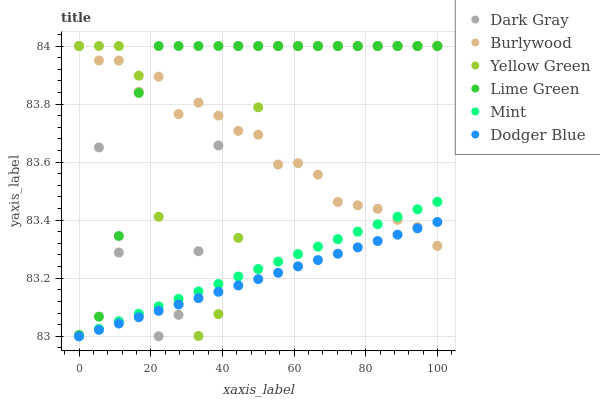Does Dodger Blue have the minimum area under the curve?
Answer yes or no. Yes. Does Lime Green have the maximum area under the curve?
Answer yes or no. Yes. Does Burlywood have the minimum area under the curve?
Answer yes or no. No. Does Burlywood have the maximum area under the curve?
Answer yes or no. No. Is Mint the smoothest?
Answer yes or no. Yes. Is Yellow Green the roughest?
Answer yes or no. Yes. Is Burlywood the smoothest?
Answer yes or no. No. Is Burlywood the roughest?
Answer yes or no. No. Does Dodger Blue have the lowest value?
Answer yes or no. Yes. Does Lime Green have the lowest value?
Answer yes or no. No. Does Dark Gray have the highest value?
Answer yes or no. Yes. Does Dodger Blue have the highest value?
Answer yes or no. No. Is Dodger Blue less than Lime Green?
Answer yes or no. Yes. Is Lime Green greater than Mint?
Answer yes or no. Yes. Does Yellow Green intersect Dodger Blue?
Answer yes or no. Yes. Is Yellow Green less than Dodger Blue?
Answer yes or no. No. Is Yellow Green greater than Dodger Blue?
Answer yes or no. No. Does Dodger Blue intersect Lime Green?
Answer yes or no. No. 